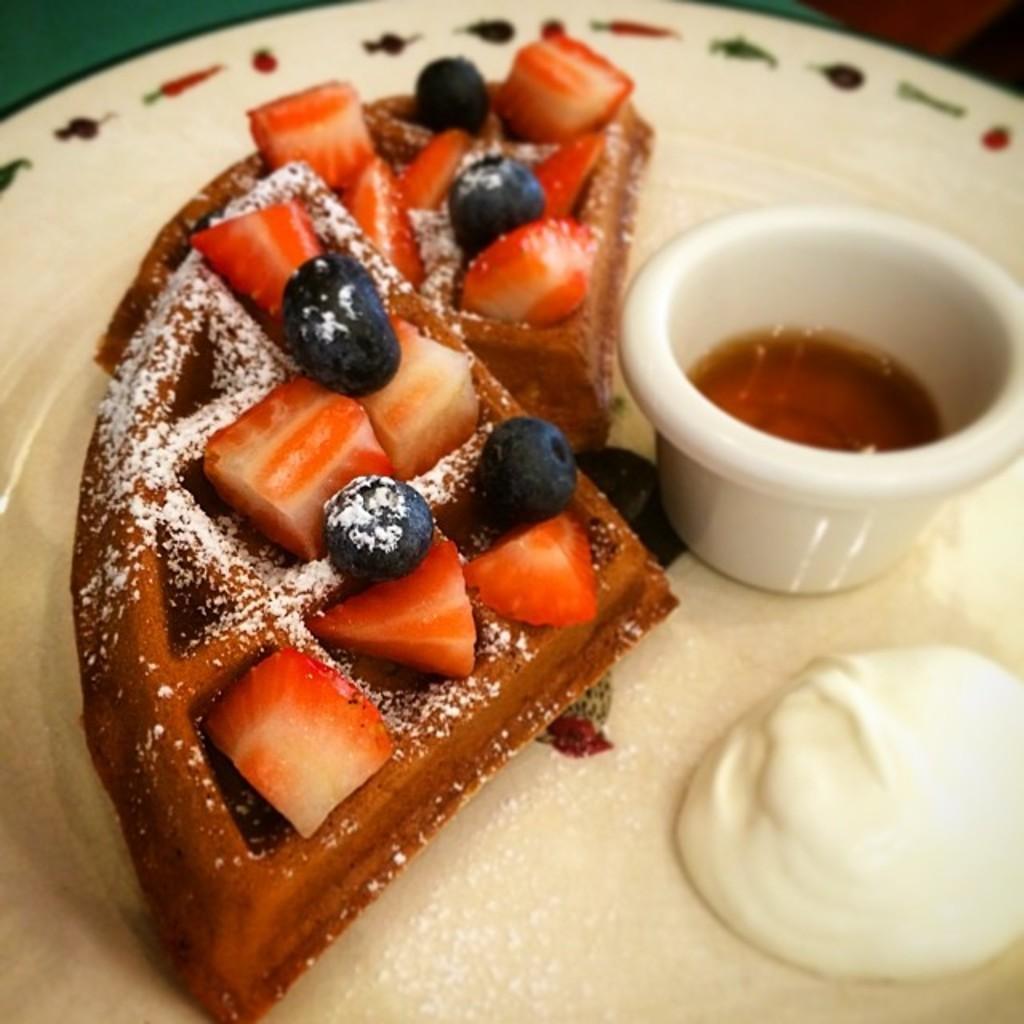Can you describe this image briefly? In this image there are some food items and a small cup with some sauce are on the plate. 